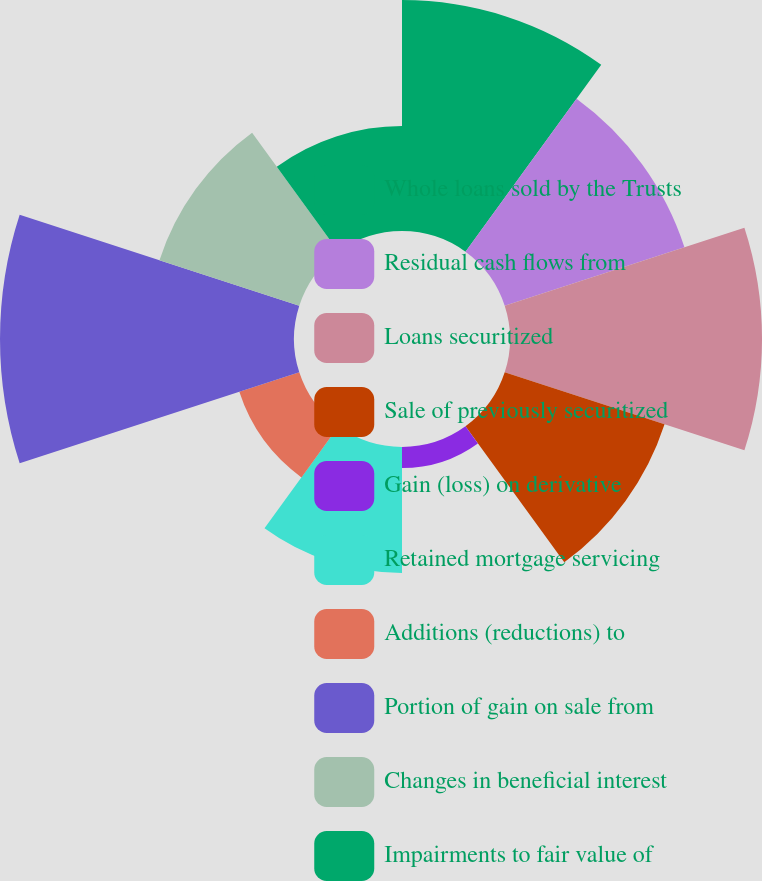<chart> <loc_0><loc_0><loc_500><loc_500><pie_chart><fcel>Whole loans sold by the Trusts<fcel>Residual cash flows from<fcel>Loans securitized<fcel>Sale of previously securitized<fcel>Gain (loss) on derivative<fcel>Retained mortgage servicing<fcel>Additions (reductions) to<fcel>Portion of gain on sale from<fcel>Changes in beneficial interest<fcel>Impairments to fair value of<nl><fcel>14.47%<fcel>11.84%<fcel>15.79%<fcel>10.53%<fcel>1.32%<fcel>7.89%<fcel>3.95%<fcel>18.42%<fcel>9.21%<fcel>6.58%<nl></chart> 